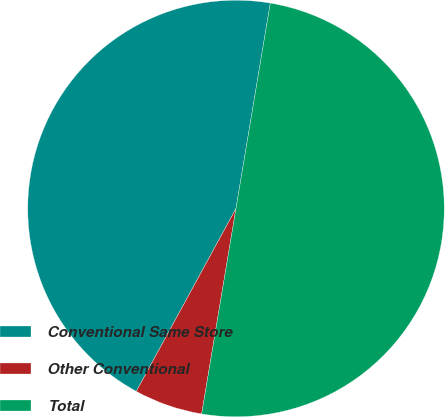Convert chart. <chart><loc_0><loc_0><loc_500><loc_500><pie_chart><fcel>Conventional Same Store<fcel>Other Conventional<fcel>Total<nl><fcel>44.69%<fcel>5.31%<fcel>50.0%<nl></chart> 